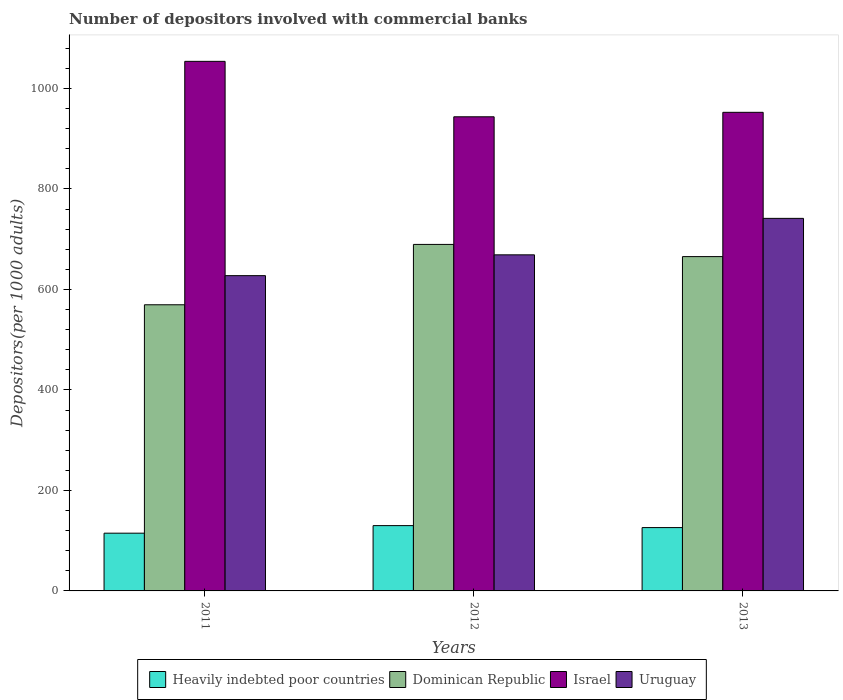How many different coloured bars are there?
Make the answer very short. 4. How many groups of bars are there?
Make the answer very short. 3. Are the number of bars per tick equal to the number of legend labels?
Your answer should be compact. Yes. How many bars are there on the 2nd tick from the right?
Give a very brief answer. 4. In how many cases, is the number of bars for a given year not equal to the number of legend labels?
Your response must be concise. 0. What is the number of depositors involved with commercial banks in Israel in 2013?
Offer a very short reply. 952.62. Across all years, what is the maximum number of depositors involved with commercial banks in Uruguay?
Keep it short and to the point. 741.55. Across all years, what is the minimum number of depositors involved with commercial banks in Heavily indebted poor countries?
Your answer should be compact. 114.93. In which year was the number of depositors involved with commercial banks in Dominican Republic maximum?
Ensure brevity in your answer.  2012. In which year was the number of depositors involved with commercial banks in Uruguay minimum?
Ensure brevity in your answer.  2011. What is the total number of depositors involved with commercial banks in Uruguay in the graph?
Give a very brief answer. 2038.04. What is the difference between the number of depositors involved with commercial banks in Uruguay in 2012 and that in 2013?
Give a very brief answer. -72.59. What is the difference between the number of depositors involved with commercial banks in Israel in 2011 and the number of depositors involved with commercial banks in Dominican Republic in 2012?
Your answer should be compact. 364.36. What is the average number of depositors involved with commercial banks in Uruguay per year?
Offer a terse response. 679.35. In the year 2011, what is the difference between the number of depositors involved with commercial banks in Heavily indebted poor countries and number of depositors involved with commercial banks in Dominican Republic?
Give a very brief answer. -454.62. What is the ratio of the number of depositors involved with commercial banks in Heavily indebted poor countries in 2011 to that in 2012?
Your response must be concise. 0.88. Is the number of depositors involved with commercial banks in Dominican Republic in 2011 less than that in 2013?
Your response must be concise. Yes. Is the difference between the number of depositors involved with commercial banks in Heavily indebted poor countries in 2011 and 2012 greater than the difference between the number of depositors involved with commercial banks in Dominican Republic in 2011 and 2012?
Your answer should be compact. Yes. What is the difference between the highest and the second highest number of depositors involved with commercial banks in Dominican Republic?
Make the answer very short. 24.27. What is the difference between the highest and the lowest number of depositors involved with commercial banks in Uruguay?
Your answer should be compact. 114.02. In how many years, is the number of depositors involved with commercial banks in Heavily indebted poor countries greater than the average number of depositors involved with commercial banks in Heavily indebted poor countries taken over all years?
Provide a succinct answer. 2. Is the sum of the number of depositors involved with commercial banks in Dominican Republic in 2011 and 2013 greater than the maximum number of depositors involved with commercial banks in Heavily indebted poor countries across all years?
Provide a short and direct response. Yes. Is it the case that in every year, the sum of the number of depositors involved with commercial banks in Heavily indebted poor countries and number of depositors involved with commercial banks in Uruguay is greater than the sum of number of depositors involved with commercial banks in Dominican Republic and number of depositors involved with commercial banks in Israel?
Offer a very short reply. No. What does the 4th bar from the left in 2011 represents?
Provide a succinct answer. Uruguay. What does the 4th bar from the right in 2012 represents?
Your answer should be compact. Heavily indebted poor countries. Is it the case that in every year, the sum of the number of depositors involved with commercial banks in Uruguay and number of depositors involved with commercial banks in Heavily indebted poor countries is greater than the number of depositors involved with commercial banks in Israel?
Ensure brevity in your answer.  No. How many bars are there?
Your response must be concise. 12. Are all the bars in the graph horizontal?
Offer a terse response. No. What is the difference between two consecutive major ticks on the Y-axis?
Provide a short and direct response. 200. Does the graph contain grids?
Make the answer very short. No. What is the title of the graph?
Provide a short and direct response. Number of depositors involved with commercial banks. Does "United Arab Emirates" appear as one of the legend labels in the graph?
Offer a terse response. No. What is the label or title of the Y-axis?
Your response must be concise. Depositors(per 1000 adults). What is the Depositors(per 1000 adults) of Heavily indebted poor countries in 2011?
Your answer should be very brief. 114.93. What is the Depositors(per 1000 adults) in Dominican Republic in 2011?
Offer a terse response. 569.55. What is the Depositors(per 1000 adults) of Israel in 2011?
Your answer should be compact. 1054.06. What is the Depositors(per 1000 adults) in Uruguay in 2011?
Offer a terse response. 627.53. What is the Depositors(per 1000 adults) in Heavily indebted poor countries in 2012?
Offer a terse response. 129.98. What is the Depositors(per 1000 adults) in Dominican Republic in 2012?
Make the answer very short. 689.69. What is the Depositors(per 1000 adults) in Israel in 2012?
Offer a terse response. 943.72. What is the Depositors(per 1000 adults) of Uruguay in 2012?
Your response must be concise. 668.96. What is the Depositors(per 1000 adults) in Heavily indebted poor countries in 2013?
Your response must be concise. 126.07. What is the Depositors(per 1000 adults) of Dominican Republic in 2013?
Your answer should be compact. 665.43. What is the Depositors(per 1000 adults) in Israel in 2013?
Offer a terse response. 952.62. What is the Depositors(per 1000 adults) in Uruguay in 2013?
Offer a very short reply. 741.55. Across all years, what is the maximum Depositors(per 1000 adults) in Heavily indebted poor countries?
Offer a very short reply. 129.98. Across all years, what is the maximum Depositors(per 1000 adults) in Dominican Republic?
Provide a succinct answer. 689.69. Across all years, what is the maximum Depositors(per 1000 adults) of Israel?
Your answer should be compact. 1054.06. Across all years, what is the maximum Depositors(per 1000 adults) in Uruguay?
Provide a short and direct response. 741.55. Across all years, what is the minimum Depositors(per 1000 adults) of Heavily indebted poor countries?
Your answer should be compact. 114.93. Across all years, what is the minimum Depositors(per 1000 adults) of Dominican Republic?
Make the answer very short. 569.55. Across all years, what is the minimum Depositors(per 1000 adults) in Israel?
Make the answer very short. 943.72. Across all years, what is the minimum Depositors(per 1000 adults) of Uruguay?
Your answer should be very brief. 627.53. What is the total Depositors(per 1000 adults) of Heavily indebted poor countries in the graph?
Keep it short and to the point. 370.99. What is the total Depositors(per 1000 adults) of Dominican Republic in the graph?
Your answer should be very brief. 1924.68. What is the total Depositors(per 1000 adults) in Israel in the graph?
Your answer should be compact. 2950.4. What is the total Depositors(per 1000 adults) of Uruguay in the graph?
Offer a terse response. 2038.04. What is the difference between the Depositors(per 1000 adults) of Heavily indebted poor countries in 2011 and that in 2012?
Provide a short and direct response. -15.05. What is the difference between the Depositors(per 1000 adults) in Dominican Republic in 2011 and that in 2012?
Provide a short and direct response. -120.14. What is the difference between the Depositors(per 1000 adults) in Israel in 2011 and that in 2012?
Your answer should be compact. 110.33. What is the difference between the Depositors(per 1000 adults) in Uruguay in 2011 and that in 2012?
Offer a terse response. -41.43. What is the difference between the Depositors(per 1000 adults) of Heavily indebted poor countries in 2011 and that in 2013?
Your answer should be compact. -11.14. What is the difference between the Depositors(per 1000 adults) in Dominican Republic in 2011 and that in 2013?
Keep it short and to the point. -95.87. What is the difference between the Depositors(per 1000 adults) of Israel in 2011 and that in 2013?
Provide a short and direct response. 101.44. What is the difference between the Depositors(per 1000 adults) in Uruguay in 2011 and that in 2013?
Offer a very short reply. -114.02. What is the difference between the Depositors(per 1000 adults) in Heavily indebted poor countries in 2012 and that in 2013?
Offer a terse response. 3.91. What is the difference between the Depositors(per 1000 adults) of Dominican Republic in 2012 and that in 2013?
Your answer should be very brief. 24.27. What is the difference between the Depositors(per 1000 adults) in Israel in 2012 and that in 2013?
Offer a very short reply. -8.9. What is the difference between the Depositors(per 1000 adults) in Uruguay in 2012 and that in 2013?
Your response must be concise. -72.59. What is the difference between the Depositors(per 1000 adults) in Heavily indebted poor countries in 2011 and the Depositors(per 1000 adults) in Dominican Republic in 2012?
Your answer should be very brief. -574.76. What is the difference between the Depositors(per 1000 adults) of Heavily indebted poor countries in 2011 and the Depositors(per 1000 adults) of Israel in 2012?
Give a very brief answer. -828.79. What is the difference between the Depositors(per 1000 adults) in Heavily indebted poor countries in 2011 and the Depositors(per 1000 adults) in Uruguay in 2012?
Provide a succinct answer. -554.03. What is the difference between the Depositors(per 1000 adults) of Dominican Republic in 2011 and the Depositors(per 1000 adults) of Israel in 2012?
Give a very brief answer. -374.17. What is the difference between the Depositors(per 1000 adults) in Dominican Republic in 2011 and the Depositors(per 1000 adults) in Uruguay in 2012?
Make the answer very short. -99.41. What is the difference between the Depositors(per 1000 adults) in Israel in 2011 and the Depositors(per 1000 adults) in Uruguay in 2012?
Ensure brevity in your answer.  385.1. What is the difference between the Depositors(per 1000 adults) in Heavily indebted poor countries in 2011 and the Depositors(per 1000 adults) in Dominican Republic in 2013?
Offer a terse response. -550.49. What is the difference between the Depositors(per 1000 adults) of Heavily indebted poor countries in 2011 and the Depositors(per 1000 adults) of Israel in 2013?
Your response must be concise. -837.69. What is the difference between the Depositors(per 1000 adults) of Heavily indebted poor countries in 2011 and the Depositors(per 1000 adults) of Uruguay in 2013?
Your response must be concise. -626.61. What is the difference between the Depositors(per 1000 adults) of Dominican Republic in 2011 and the Depositors(per 1000 adults) of Israel in 2013?
Provide a succinct answer. -383.07. What is the difference between the Depositors(per 1000 adults) in Dominican Republic in 2011 and the Depositors(per 1000 adults) in Uruguay in 2013?
Offer a very short reply. -172. What is the difference between the Depositors(per 1000 adults) in Israel in 2011 and the Depositors(per 1000 adults) in Uruguay in 2013?
Offer a very short reply. 312.51. What is the difference between the Depositors(per 1000 adults) of Heavily indebted poor countries in 2012 and the Depositors(per 1000 adults) of Dominican Republic in 2013?
Your response must be concise. -535.45. What is the difference between the Depositors(per 1000 adults) in Heavily indebted poor countries in 2012 and the Depositors(per 1000 adults) in Israel in 2013?
Ensure brevity in your answer.  -822.64. What is the difference between the Depositors(per 1000 adults) in Heavily indebted poor countries in 2012 and the Depositors(per 1000 adults) in Uruguay in 2013?
Your answer should be compact. -611.57. What is the difference between the Depositors(per 1000 adults) of Dominican Republic in 2012 and the Depositors(per 1000 adults) of Israel in 2013?
Provide a short and direct response. -262.93. What is the difference between the Depositors(per 1000 adults) of Dominican Republic in 2012 and the Depositors(per 1000 adults) of Uruguay in 2013?
Keep it short and to the point. -51.85. What is the difference between the Depositors(per 1000 adults) in Israel in 2012 and the Depositors(per 1000 adults) in Uruguay in 2013?
Give a very brief answer. 202.18. What is the average Depositors(per 1000 adults) of Heavily indebted poor countries per year?
Your response must be concise. 123.66. What is the average Depositors(per 1000 adults) of Dominican Republic per year?
Ensure brevity in your answer.  641.56. What is the average Depositors(per 1000 adults) in Israel per year?
Offer a terse response. 983.47. What is the average Depositors(per 1000 adults) of Uruguay per year?
Offer a very short reply. 679.35. In the year 2011, what is the difference between the Depositors(per 1000 adults) of Heavily indebted poor countries and Depositors(per 1000 adults) of Dominican Republic?
Offer a very short reply. -454.62. In the year 2011, what is the difference between the Depositors(per 1000 adults) in Heavily indebted poor countries and Depositors(per 1000 adults) in Israel?
Provide a short and direct response. -939.12. In the year 2011, what is the difference between the Depositors(per 1000 adults) in Heavily indebted poor countries and Depositors(per 1000 adults) in Uruguay?
Ensure brevity in your answer.  -512.6. In the year 2011, what is the difference between the Depositors(per 1000 adults) in Dominican Republic and Depositors(per 1000 adults) in Israel?
Offer a very short reply. -484.5. In the year 2011, what is the difference between the Depositors(per 1000 adults) of Dominican Republic and Depositors(per 1000 adults) of Uruguay?
Ensure brevity in your answer.  -57.98. In the year 2011, what is the difference between the Depositors(per 1000 adults) in Israel and Depositors(per 1000 adults) in Uruguay?
Offer a terse response. 426.53. In the year 2012, what is the difference between the Depositors(per 1000 adults) in Heavily indebted poor countries and Depositors(per 1000 adults) in Dominican Republic?
Make the answer very short. -559.71. In the year 2012, what is the difference between the Depositors(per 1000 adults) of Heavily indebted poor countries and Depositors(per 1000 adults) of Israel?
Provide a succinct answer. -813.74. In the year 2012, what is the difference between the Depositors(per 1000 adults) of Heavily indebted poor countries and Depositors(per 1000 adults) of Uruguay?
Keep it short and to the point. -538.98. In the year 2012, what is the difference between the Depositors(per 1000 adults) in Dominican Republic and Depositors(per 1000 adults) in Israel?
Offer a very short reply. -254.03. In the year 2012, what is the difference between the Depositors(per 1000 adults) of Dominican Republic and Depositors(per 1000 adults) of Uruguay?
Your answer should be compact. 20.73. In the year 2012, what is the difference between the Depositors(per 1000 adults) of Israel and Depositors(per 1000 adults) of Uruguay?
Provide a succinct answer. 274.76. In the year 2013, what is the difference between the Depositors(per 1000 adults) of Heavily indebted poor countries and Depositors(per 1000 adults) of Dominican Republic?
Offer a terse response. -539.36. In the year 2013, what is the difference between the Depositors(per 1000 adults) in Heavily indebted poor countries and Depositors(per 1000 adults) in Israel?
Ensure brevity in your answer.  -826.55. In the year 2013, what is the difference between the Depositors(per 1000 adults) in Heavily indebted poor countries and Depositors(per 1000 adults) in Uruguay?
Your response must be concise. -615.48. In the year 2013, what is the difference between the Depositors(per 1000 adults) in Dominican Republic and Depositors(per 1000 adults) in Israel?
Provide a succinct answer. -287.19. In the year 2013, what is the difference between the Depositors(per 1000 adults) of Dominican Republic and Depositors(per 1000 adults) of Uruguay?
Make the answer very short. -76.12. In the year 2013, what is the difference between the Depositors(per 1000 adults) in Israel and Depositors(per 1000 adults) in Uruguay?
Keep it short and to the point. 211.07. What is the ratio of the Depositors(per 1000 adults) in Heavily indebted poor countries in 2011 to that in 2012?
Offer a terse response. 0.88. What is the ratio of the Depositors(per 1000 adults) of Dominican Republic in 2011 to that in 2012?
Your answer should be very brief. 0.83. What is the ratio of the Depositors(per 1000 adults) in Israel in 2011 to that in 2012?
Give a very brief answer. 1.12. What is the ratio of the Depositors(per 1000 adults) in Uruguay in 2011 to that in 2012?
Offer a very short reply. 0.94. What is the ratio of the Depositors(per 1000 adults) in Heavily indebted poor countries in 2011 to that in 2013?
Your answer should be very brief. 0.91. What is the ratio of the Depositors(per 1000 adults) of Dominican Republic in 2011 to that in 2013?
Keep it short and to the point. 0.86. What is the ratio of the Depositors(per 1000 adults) of Israel in 2011 to that in 2013?
Provide a succinct answer. 1.11. What is the ratio of the Depositors(per 1000 adults) of Uruguay in 2011 to that in 2013?
Offer a terse response. 0.85. What is the ratio of the Depositors(per 1000 adults) of Heavily indebted poor countries in 2012 to that in 2013?
Ensure brevity in your answer.  1.03. What is the ratio of the Depositors(per 1000 adults) of Dominican Republic in 2012 to that in 2013?
Keep it short and to the point. 1.04. What is the ratio of the Depositors(per 1000 adults) in Israel in 2012 to that in 2013?
Keep it short and to the point. 0.99. What is the ratio of the Depositors(per 1000 adults) in Uruguay in 2012 to that in 2013?
Provide a short and direct response. 0.9. What is the difference between the highest and the second highest Depositors(per 1000 adults) in Heavily indebted poor countries?
Provide a succinct answer. 3.91. What is the difference between the highest and the second highest Depositors(per 1000 adults) in Dominican Republic?
Make the answer very short. 24.27. What is the difference between the highest and the second highest Depositors(per 1000 adults) in Israel?
Provide a succinct answer. 101.44. What is the difference between the highest and the second highest Depositors(per 1000 adults) of Uruguay?
Make the answer very short. 72.59. What is the difference between the highest and the lowest Depositors(per 1000 adults) of Heavily indebted poor countries?
Your answer should be very brief. 15.05. What is the difference between the highest and the lowest Depositors(per 1000 adults) of Dominican Republic?
Your answer should be very brief. 120.14. What is the difference between the highest and the lowest Depositors(per 1000 adults) in Israel?
Your answer should be very brief. 110.33. What is the difference between the highest and the lowest Depositors(per 1000 adults) of Uruguay?
Keep it short and to the point. 114.02. 